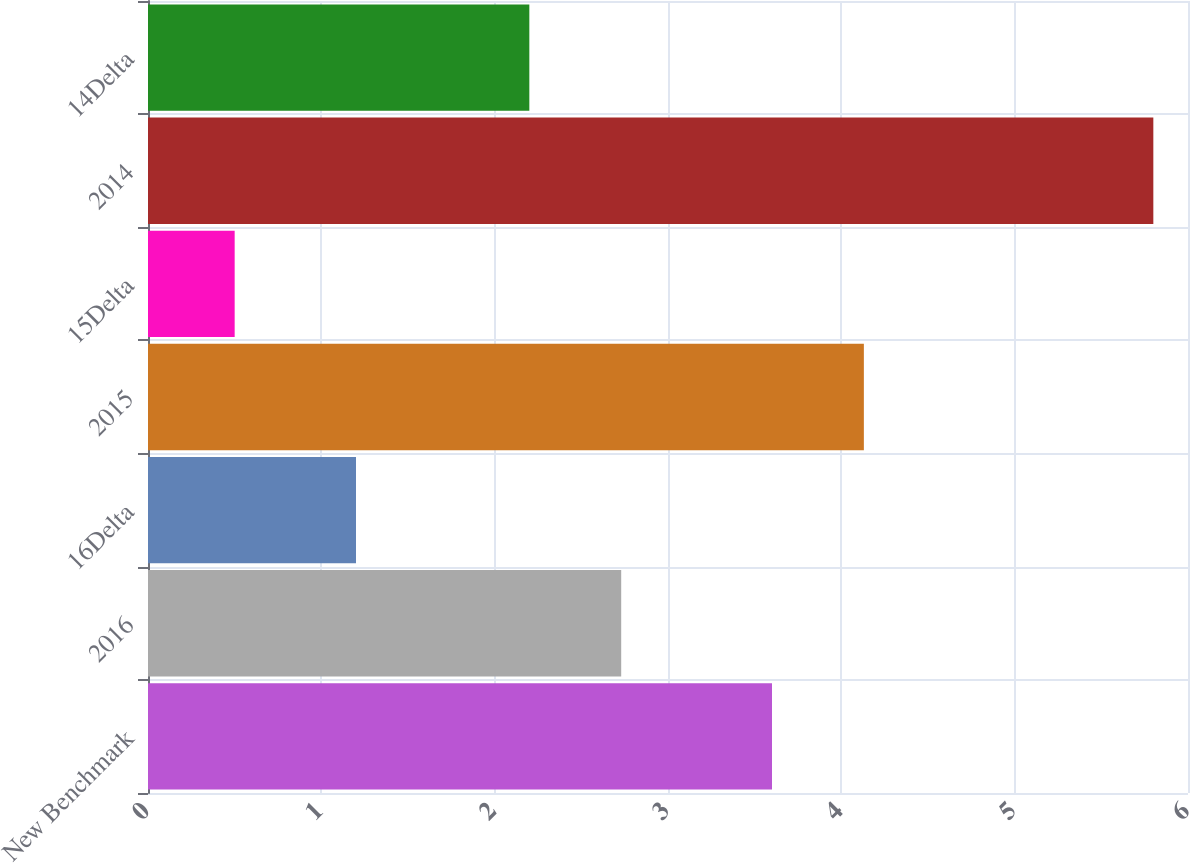<chart> <loc_0><loc_0><loc_500><loc_500><bar_chart><fcel>New Benchmark<fcel>2016<fcel>16Delta<fcel>2015<fcel>15Delta<fcel>2014<fcel>14Delta<nl><fcel>3.6<fcel>2.73<fcel>1.2<fcel>4.13<fcel>0.5<fcel>5.8<fcel>2.2<nl></chart> 